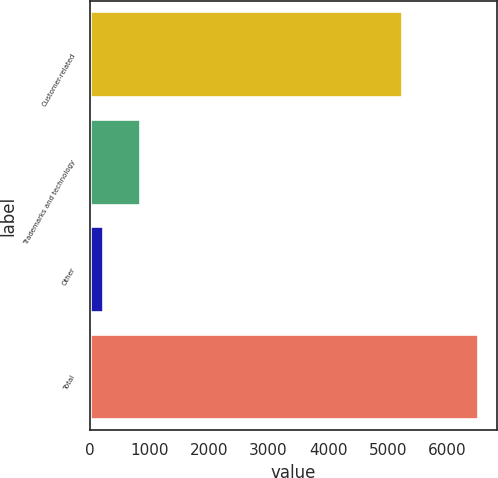Convert chart. <chart><loc_0><loc_0><loc_500><loc_500><bar_chart><fcel>Customer-related<fcel>Trademarks and technology<fcel>Other<fcel>Total<nl><fcel>5229<fcel>849.5<fcel>221<fcel>6506<nl></chart> 